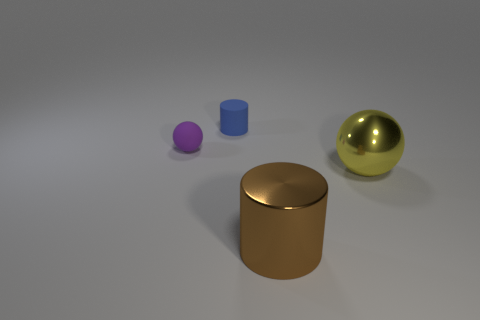The large ball is what color?
Make the answer very short. Yellow. What is the size of the yellow ball that is the same material as the brown cylinder?
Make the answer very short. Large. There is a shiny object that is in front of the large object that is behind the brown shiny thing; what number of tiny purple rubber objects are left of it?
Keep it short and to the point. 1. Does the matte cylinder have the same color as the cylinder that is in front of the big yellow object?
Provide a short and direct response. No. The thing that is on the right side of the big object that is in front of the metal object on the right side of the shiny cylinder is made of what material?
Your answer should be very brief. Metal. There is a object that is left of the small matte cylinder; is its shape the same as the blue thing?
Offer a very short reply. No. There is a large object left of the big yellow ball; what is it made of?
Provide a short and direct response. Metal. What number of metal objects are either small purple balls or cyan balls?
Ensure brevity in your answer.  0. Are there any yellow shiny things of the same size as the purple ball?
Your answer should be very brief. No. Is the number of big brown cylinders that are in front of the large yellow object greater than the number of yellow rubber spheres?
Make the answer very short. Yes. 